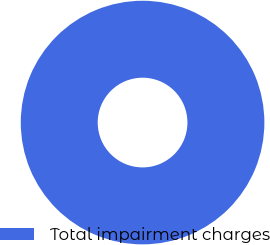Convert chart. <chart><loc_0><loc_0><loc_500><loc_500><pie_chart><fcel>Total impairment charges<nl><fcel>100.0%<nl></chart> 